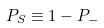<formula> <loc_0><loc_0><loc_500><loc_500>P _ { S } \equiv 1 - P _ { - }</formula> 